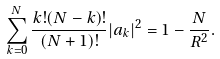Convert formula to latex. <formula><loc_0><loc_0><loc_500><loc_500>\sum _ { k = 0 } ^ { N } \frac { k ! ( N - k ) ! } { ( N + 1 ) ! } | a _ { k } | ^ { 2 } = 1 - \frac { N } { R ^ { 2 } } .</formula> 